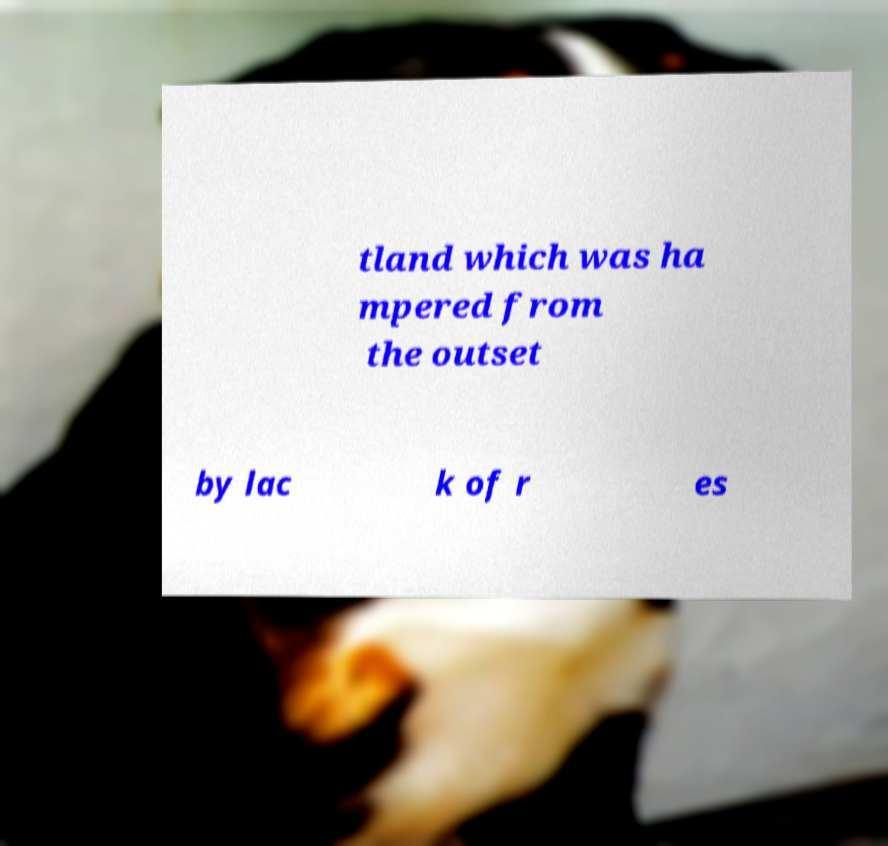Please identify and transcribe the text found in this image. tland which was ha mpered from the outset by lac k of r es 